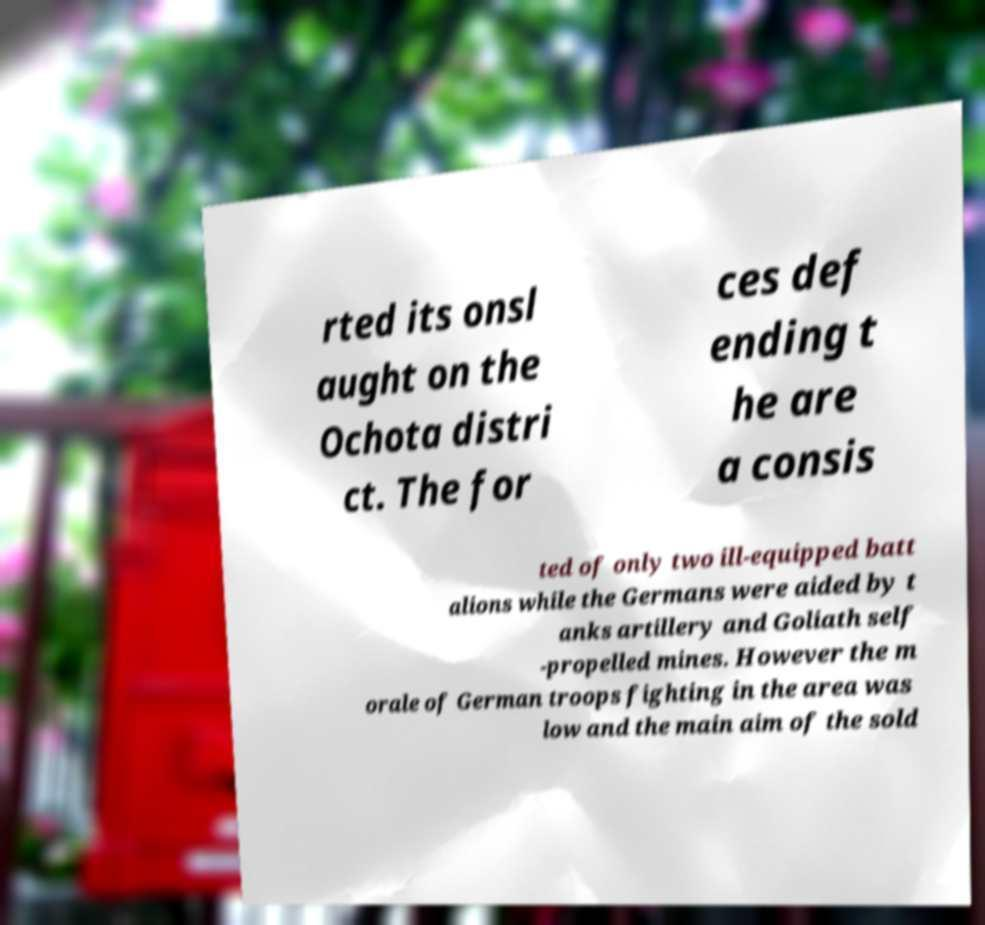Please identify and transcribe the text found in this image. rted its onsl aught on the Ochota distri ct. The for ces def ending t he are a consis ted of only two ill-equipped batt alions while the Germans were aided by t anks artillery and Goliath self -propelled mines. However the m orale of German troops fighting in the area was low and the main aim of the sold 